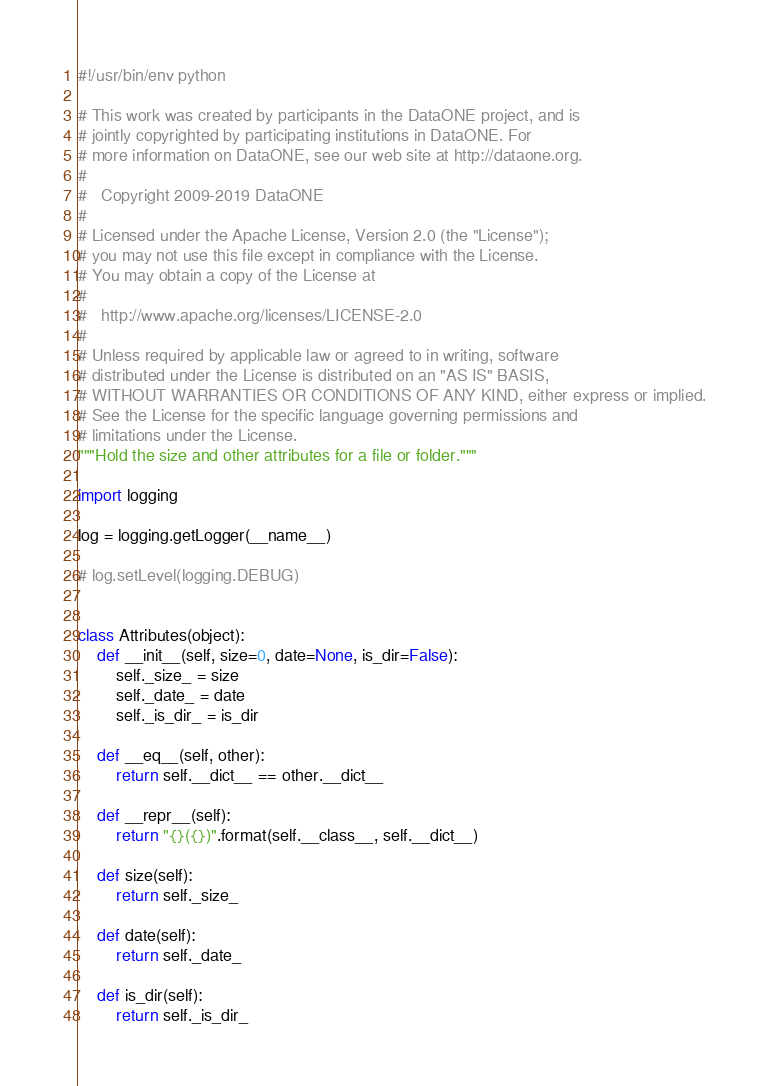Convert code to text. <code><loc_0><loc_0><loc_500><loc_500><_Python_>#!/usr/bin/env python

# This work was created by participants in the DataONE project, and is
# jointly copyrighted by participating institutions in DataONE. For
# more information on DataONE, see our web site at http://dataone.org.
#
#   Copyright 2009-2019 DataONE
#
# Licensed under the Apache License, Version 2.0 (the "License");
# you may not use this file except in compliance with the License.
# You may obtain a copy of the License at
#
#   http://www.apache.org/licenses/LICENSE-2.0
#
# Unless required by applicable law or agreed to in writing, software
# distributed under the License is distributed on an "AS IS" BASIS,
# WITHOUT WARRANTIES OR CONDITIONS OF ANY KIND, either express or implied.
# See the License for the specific language governing permissions and
# limitations under the License.
"""Hold the size and other attributes for a file or folder."""

import logging

log = logging.getLogger(__name__)

# log.setLevel(logging.DEBUG)


class Attributes(object):
    def __init__(self, size=0, date=None, is_dir=False):
        self._size_ = size
        self._date_ = date
        self._is_dir_ = is_dir

    def __eq__(self, other):
        return self.__dict__ == other.__dict__

    def __repr__(self):
        return "{}({})".format(self.__class__, self.__dict__)

    def size(self):
        return self._size_

    def date(self):
        return self._date_

    def is_dir(self):
        return self._is_dir_
</code> 